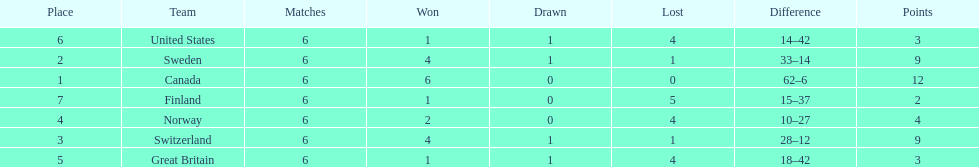Which country conceded the least goals? Finland. 